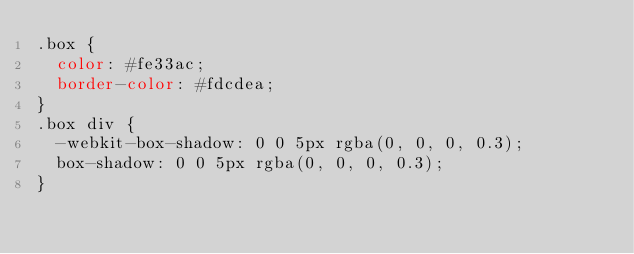<code> <loc_0><loc_0><loc_500><loc_500><_CSS_>.box {
  color: #fe33ac;
  border-color: #fdcdea;
}
.box div {
  -webkit-box-shadow: 0 0 5px rgba(0, 0, 0, 0.3);
  box-shadow: 0 0 5px rgba(0, 0, 0, 0.3);
}</code> 